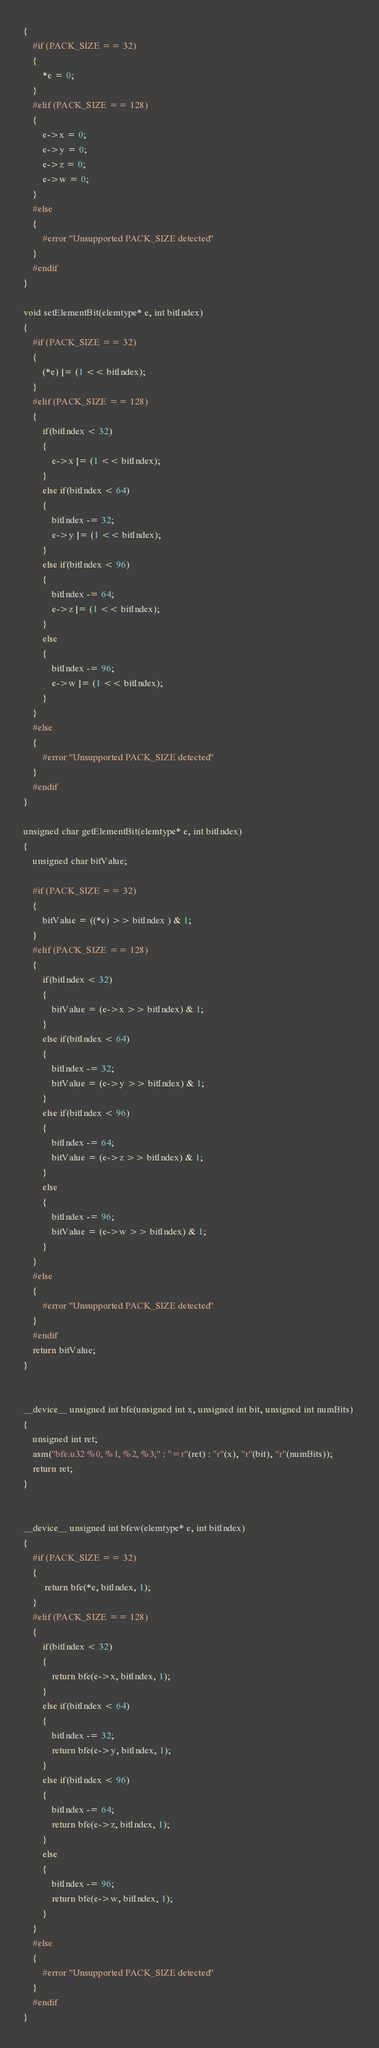<code> <loc_0><loc_0><loc_500><loc_500><_Cuda_>{
    #if (PACK_SIZE == 32)
    {
        *e = 0;
    }
    #elif (PACK_SIZE == 128)
    {
        e->x = 0;
        e->y = 0;
        e->z = 0;
        e->w = 0;
    }
    #else
    {
        #error "Unsupported PACK_SIZE detected"
    }
    #endif
}

void setElementBit(elemtype* e, int bitIndex)
{
    #if (PACK_SIZE == 32)
    {
        (*e) |= (1 << bitIndex);
    }
    #elif (PACK_SIZE == 128)
    {
        if(bitIndex < 32)
        {
            e->x |= (1 << bitIndex);
        }
        else if(bitIndex < 64)
        {
            bitIndex -= 32;
            e->y |= (1 << bitIndex);
        }
        else if(bitIndex < 96)
        {
            bitIndex -= 64;
            e->z |= (1 << bitIndex);
        }
        else
        {
            bitIndex -= 96;
            e->w |= (1 << bitIndex);
        }
    }
    #else
    {
        #error "Unsupported PACK_SIZE detected"
    }
    #endif
}

unsigned char getElementBit(elemtype* e, int bitIndex)
{
    unsigned char bitValue;

    #if (PACK_SIZE == 32)
    {
        bitValue = ((*e) >> bitIndex ) & 1;
    }
    #elif (PACK_SIZE == 128)
    {
        if(bitIndex < 32)
        {
            bitValue = (e->x >> bitIndex) & 1;
        }
        else if(bitIndex < 64)
        {
            bitIndex -= 32;
            bitValue = (e->y >> bitIndex) & 1;
        }
        else if(bitIndex < 96)
        {
            bitIndex -= 64;
            bitValue = (e->z >> bitIndex) & 1;
        }
        else
        {
            bitIndex -= 96;
            bitValue = (e->w >> bitIndex) & 1;
        }
    }
    #else
    {
        #error "Unsupported PACK_SIZE detected"
    }
    #endif
    return bitValue;
}


__device__ unsigned int bfe(unsigned int x, unsigned int bit, unsigned int numBits) 
{
    unsigned int ret;
    asm("bfe.u32 %0, %1, %2, %3;" : "=r"(ret) : "r"(x), "r"(bit), "r"(numBits));
    return ret;
}


__device__ unsigned int bfew(elemtype* e, int bitIndex)
{
    #if (PACK_SIZE == 32)
    {
         return bfe(*e, bitIndex, 1);
    }
    #elif (PACK_SIZE == 128)
    {
        if(bitIndex < 32)
        {
            return bfe(e->x, bitIndex, 1);
        }
        else if(bitIndex < 64)
        {
            bitIndex -= 32;
            return bfe(e->y, bitIndex, 1);
        }
        else if(bitIndex < 96)
        {
            bitIndex -= 64;
            return bfe(e->z, bitIndex, 1);
        }
        else
        {
            bitIndex -= 96;
            return bfe(e->w, bitIndex, 1);
        }
    }
    #else
    {
        #error "Unsupported PACK_SIZE detected"
    }
    #endif
}
</code> 